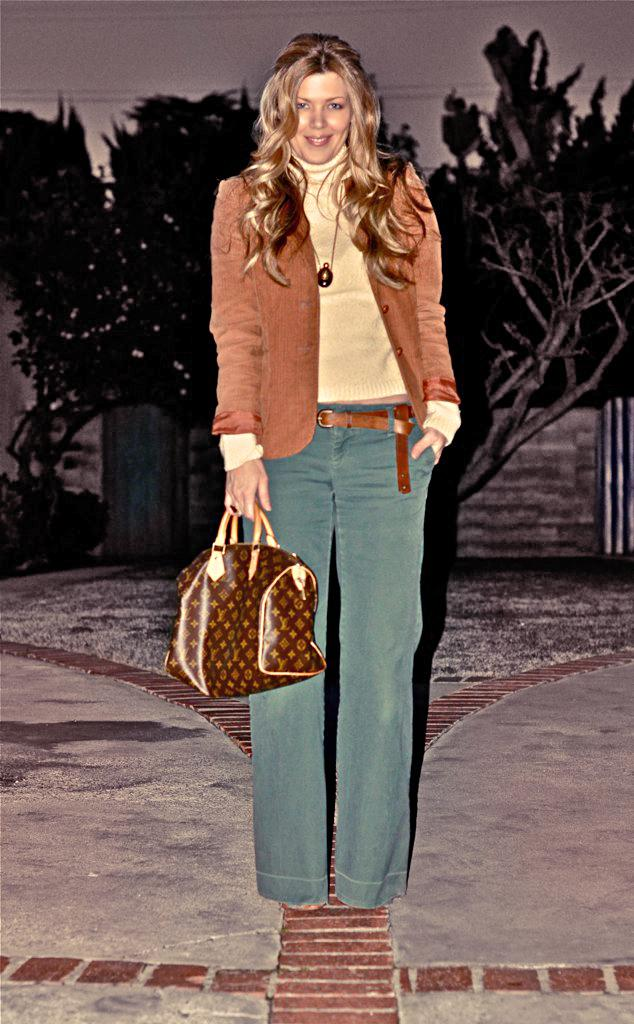Where was the image taken? The image was taken in a corridor. Who is present in the image? There is a woman in the image. What is the woman doing in the image? The woman is standing. What is the woman wearing in the image? The woman is wearing a brown jacket. What is the woman holding in the image? The woman is holding a bag in her hand. What can be seen in the background of the image? There are trees, a wall, and the sky visible in the background of the image. What type of comfort can be felt from the scent of the wilderness in the image? There is no mention of wilderness or scent in the image, so it is not possible to answer this question. 